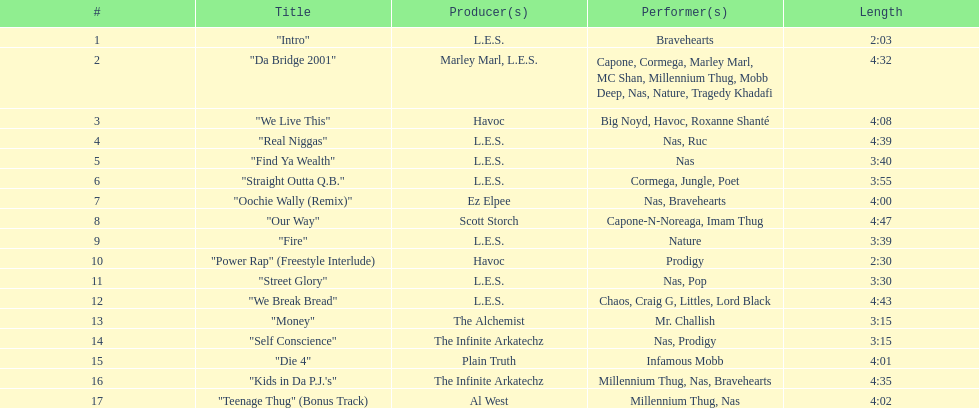How long os the longest track on the album? 4:47. 